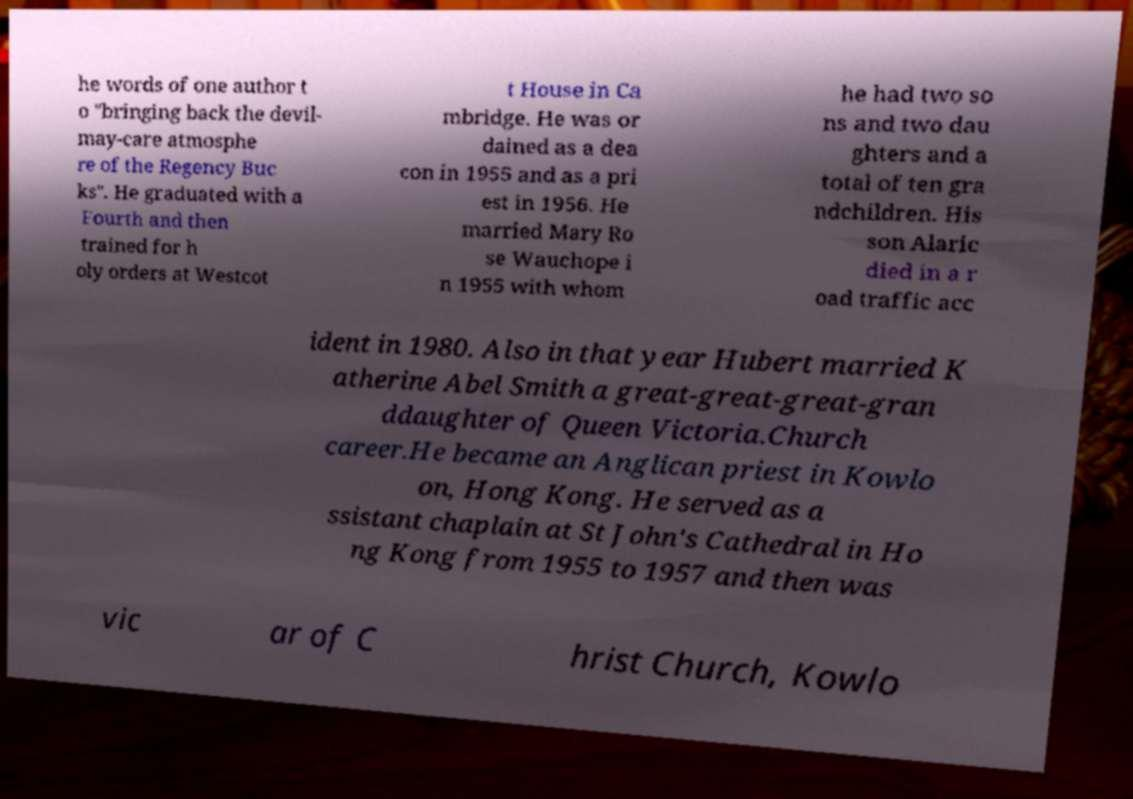Could you extract and type out the text from this image? he words of one author t o "bringing back the devil- may-care atmosphe re of the Regency Buc ks". He graduated with a Fourth and then trained for h oly orders at Westcot t House in Ca mbridge. He was or dained as a dea con in 1955 and as a pri est in 1956. He married Mary Ro se Wauchope i n 1955 with whom he had two so ns and two dau ghters and a total of ten gra ndchildren. His son Alaric died in a r oad traffic acc ident in 1980. Also in that year Hubert married K atherine Abel Smith a great-great-great-gran ddaughter of Queen Victoria.Church career.He became an Anglican priest in Kowlo on, Hong Kong. He served as a ssistant chaplain at St John's Cathedral in Ho ng Kong from 1955 to 1957 and then was vic ar of C hrist Church, Kowlo 